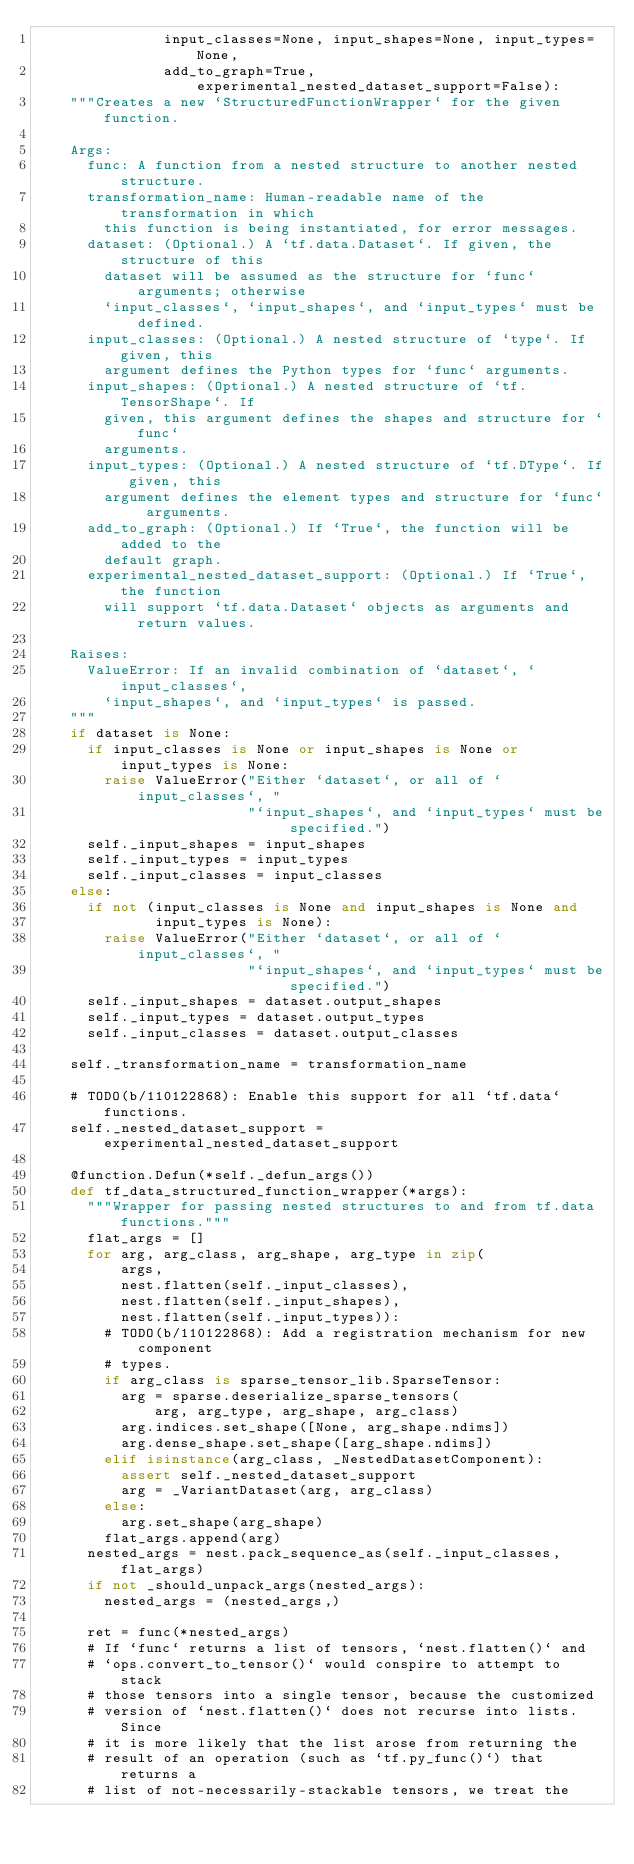<code> <loc_0><loc_0><loc_500><loc_500><_Python_>               input_classes=None, input_shapes=None, input_types=None,
               add_to_graph=True, experimental_nested_dataset_support=False):
    """Creates a new `StructuredFunctionWrapper` for the given function.

    Args:
      func: A function from a nested structure to another nested structure.
      transformation_name: Human-readable name of the transformation in which
        this function is being instantiated, for error messages.
      dataset: (Optional.) A `tf.data.Dataset`. If given, the structure of this
        dataset will be assumed as the structure for `func` arguments; otherwise
        `input_classes`, `input_shapes`, and `input_types` must be defined.
      input_classes: (Optional.) A nested structure of `type`. If given, this
        argument defines the Python types for `func` arguments.
      input_shapes: (Optional.) A nested structure of `tf.TensorShape`. If
        given, this argument defines the shapes and structure for `func`
        arguments.
      input_types: (Optional.) A nested structure of `tf.DType`. If given, this
        argument defines the element types and structure for `func` arguments.
      add_to_graph: (Optional.) If `True`, the function will be added to the
        default graph.
      experimental_nested_dataset_support: (Optional.) If `True`, the function
        will support `tf.data.Dataset` objects as arguments and return values.

    Raises:
      ValueError: If an invalid combination of `dataset`, `input_classes`,
        `input_shapes`, and `input_types` is passed.
    """
    if dataset is None:
      if input_classes is None or input_shapes is None or input_types is None:
        raise ValueError("Either `dataset`, or all of `input_classes`, "
                         "`input_shapes`, and `input_types` must be specified.")
      self._input_shapes = input_shapes
      self._input_types = input_types
      self._input_classes = input_classes
    else:
      if not (input_classes is None and input_shapes is None and
              input_types is None):
        raise ValueError("Either `dataset`, or all of `input_classes`, "
                         "`input_shapes`, and `input_types` must be specified.")
      self._input_shapes = dataset.output_shapes
      self._input_types = dataset.output_types
      self._input_classes = dataset.output_classes

    self._transformation_name = transformation_name

    # TODO(b/110122868): Enable this support for all `tf.data` functions.
    self._nested_dataset_support = experimental_nested_dataset_support

    @function.Defun(*self._defun_args())
    def tf_data_structured_function_wrapper(*args):
      """Wrapper for passing nested structures to and from tf.data functions."""
      flat_args = []
      for arg, arg_class, arg_shape, arg_type in zip(
          args,
          nest.flatten(self._input_classes),
          nest.flatten(self._input_shapes),
          nest.flatten(self._input_types)):
        # TODO(b/110122868): Add a registration mechanism for new component
        # types.
        if arg_class is sparse_tensor_lib.SparseTensor:
          arg = sparse.deserialize_sparse_tensors(
              arg, arg_type, arg_shape, arg_class)
          arg.indices.set_shape([None, arg_shape.ndims])
          arg.dense_shape.set_shape([arg_shape.ndims])
        elif isinstance(arg_class, _NestedDatasetComponent):
          assert self._nested_dataset_support
          arg = _VariantDataset(arg, arg_class)
        else:
          arg.set_shape(arg_shape)
        flat_args.append(arg)
      nested_args = nest.pack_sequence_as(self._input_classes, flat_args)
      if not _should_unpack_args(nested_args):
        nested_args = (nested_args,)

      ret = func(*nested_args)
      # If `func` returns a list of tensors, `nest.flatten()` and
      # `ops.convert_to_tensor()` would conspire to attempt to stack
      # those tensors into a single tensor, because the customized
      # version of `nest.flatten()` does not recurse into lists. Since
      # it is more likely that the list arose from returning the
      # result of an operation (such as `tf.py_func()`) that returns a
      # list of not-necessarily-stackable tensors, we treat the</code> 